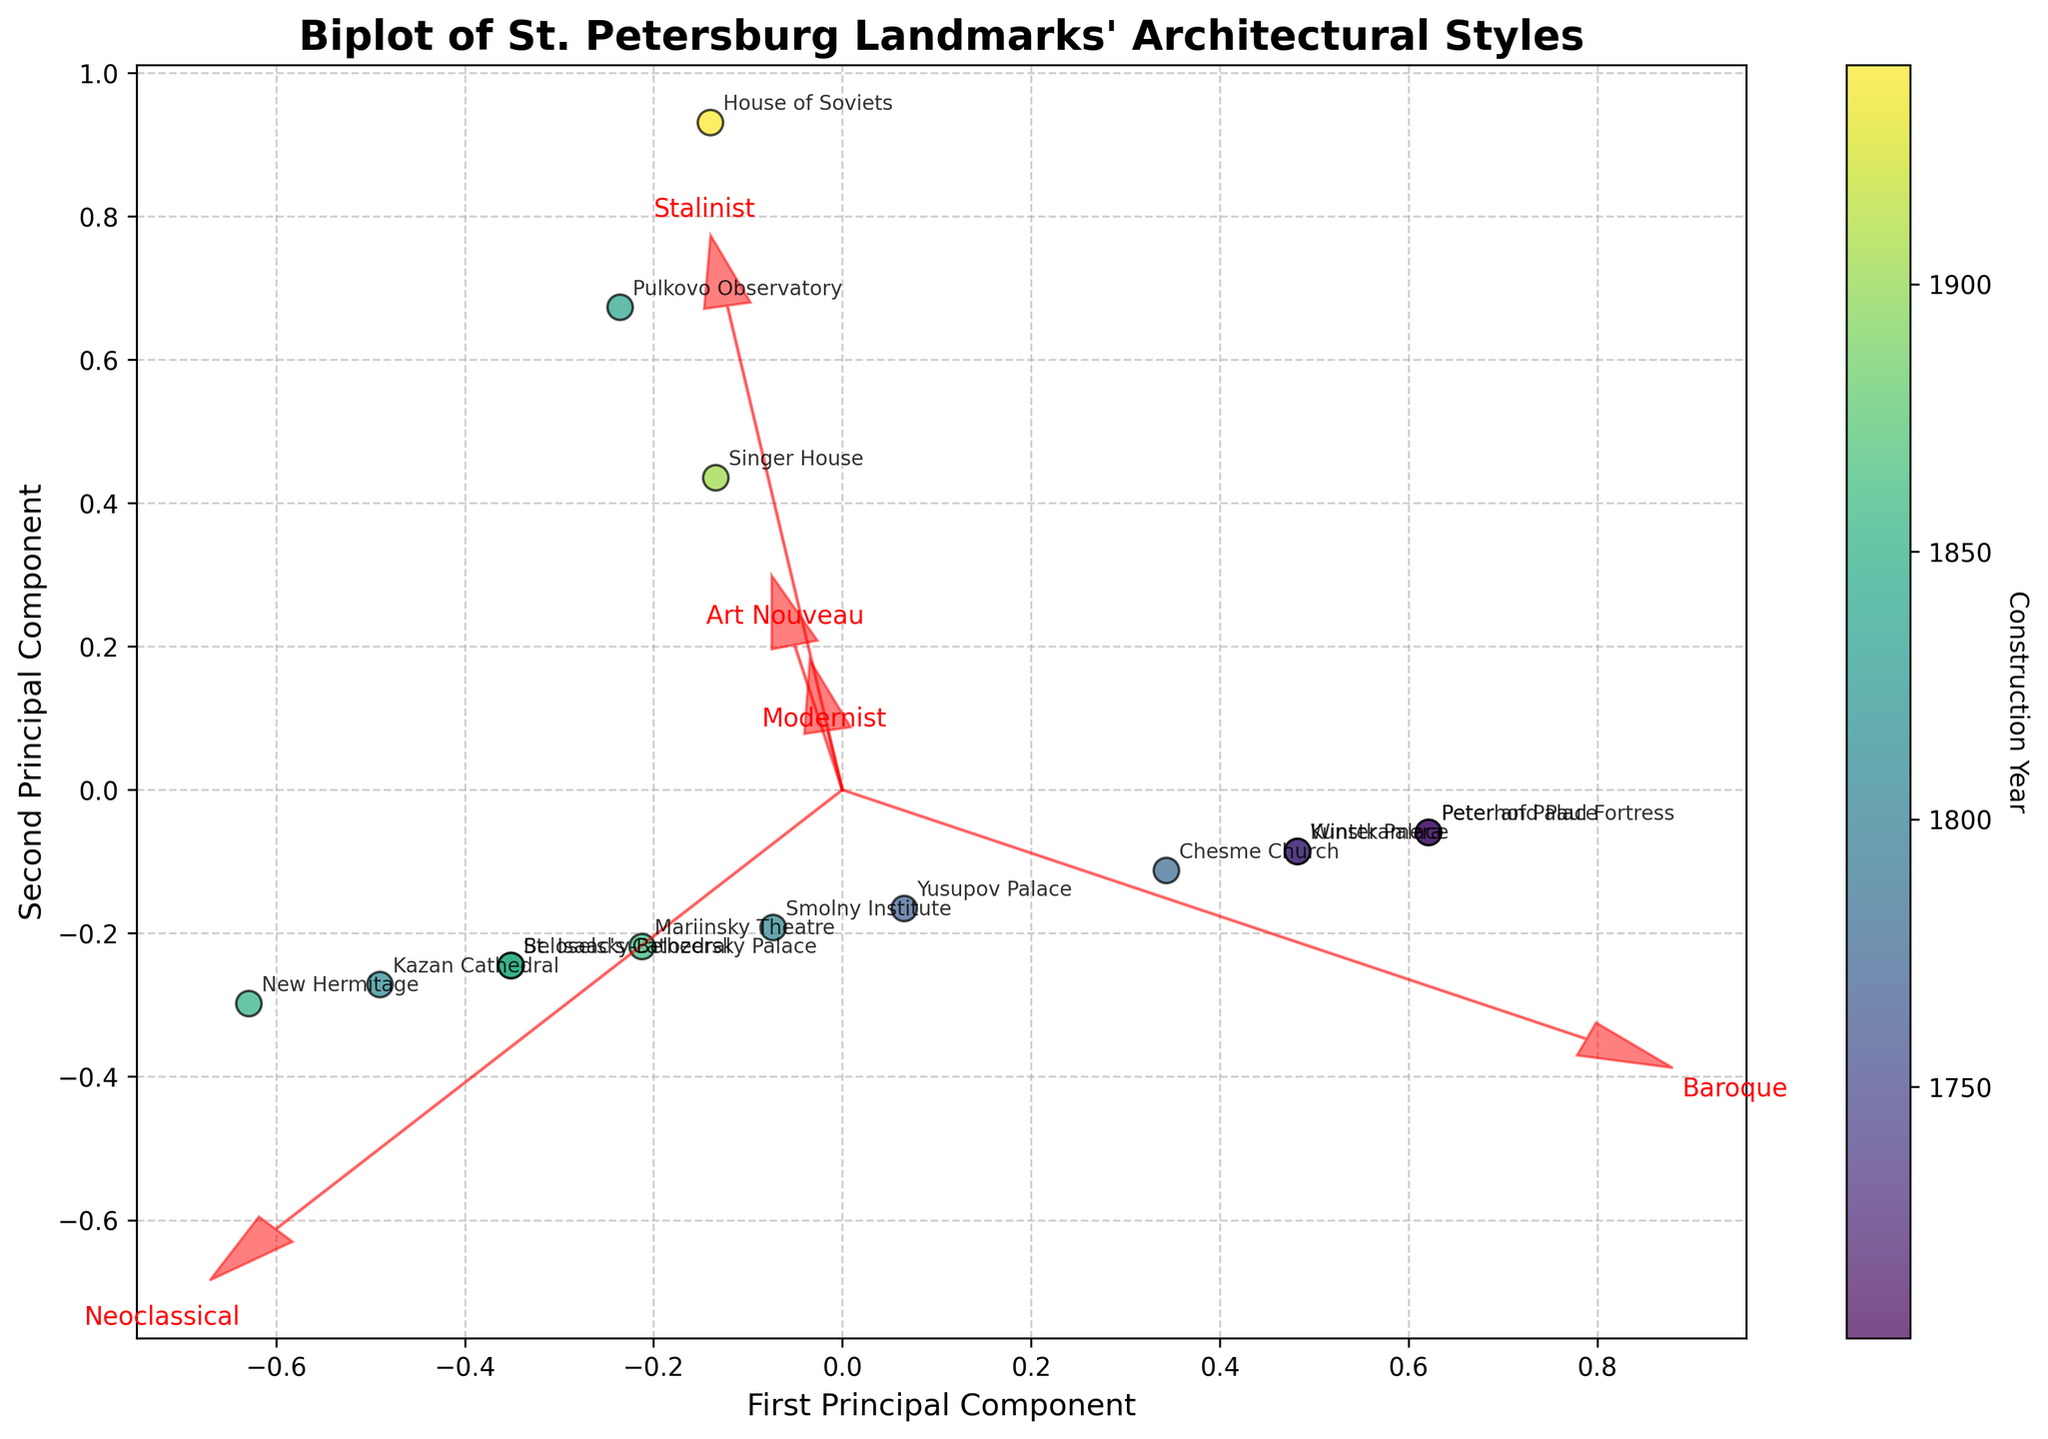What is the title of the figure? The title of the figure is often displayed at the top center and provides a summary of what the plot represents. In this case, look for words related to architectural styles and landmarks.
Answer: Biplot of St. Petersburg Landmarks' Architectural Styles Which landmark is associated with the earliest construction year in the plot? To find the earliest construction year, locate the colorbar and identify the landmark positioned closest to the segment representing the earliest date.
Answer: Peter and Paul Fortress How many arrows are drawn to represent the architectural styles, and what do they signify? Count the number of red arrows originating from the origin of the plot. These arrows represent different architectural styles. Also, look for corresponding labels next to each arrow.
Answer: 5; they signify Baroque, Neoclassical, Art Nouveau, Stalinist, Modernist Which landmark is located the furthest along the first principal component? Identify the landmark that is located at the extreme right or left along the x-axis (first principal component).
Answer: Winter Palace Which two landmarks have similar coordinates on the biplot and fall into the Neoclassical architectural style? Look for landmarks that are closely positioned on the biplot and are situated in the direction of the Neoclassical arrow. Checking the legend for their construction years can help in verifying the similarities.
Answer: Kazan Cathedral and St. Isaac's Cathedral What is the predominant architectural style of the landmarks constructed in the 18th century? Examine the position of the landmarks from the 18th century (1700s) and observe which arrow they are primarily aligned with or closest to.
Answer: Baroque Compare the positioning of Stalinist and Modernist styles. Are there landmarks associated with both these styles? If so, which ones? Observe the directions of the Stalinist and Modernist arrows; determine if any landmarks are located along or close to both arrows. Look for a landmark in the 20th-century range.
Answer: House of Soviets is associated with both Stalinist and Modernist styles How do Peter and Paul Fortress and Peterhof Palace compare in terms of their principal component scores? Locate the coordinates of both landmarks on the biplot. Analyze their relative positions along both the first and second principal components.
Answer: Both are close to each other and have high scores on the first principal component; similar positioning Based on the feature vectors, which architectural style has the least representation among the landmarks? Identify the length and direction of the red arrows. The shortest and least influential vector (as seen in the plot) indicates the least represented architectural style.
Answer: Art Nouveau What general trend do you observe regarding the construction years of landmarks and their architectural styles in the biplot? Look at the color gradient from earlier to later years on the plot and see if there is a directional trend in the positions of landmarks. This can show a transition or evolution in architectural styles over time.
Answer: Earlier landmarks are predominantly Baroque and Neoclassical, while later landmarks show diversity in styles 